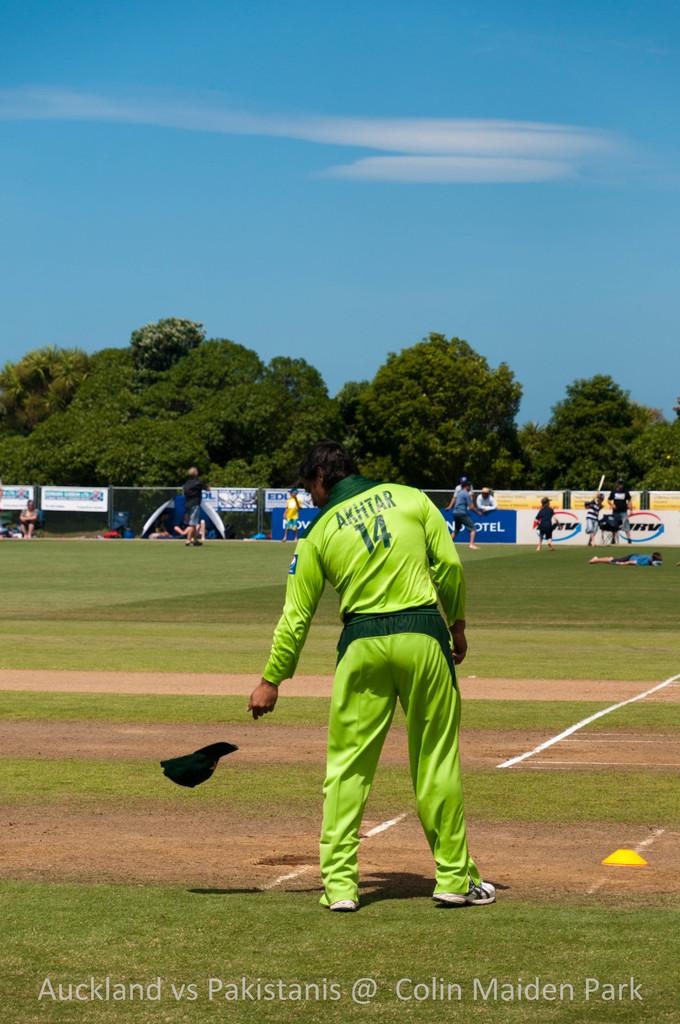What is the man in green's number?
Your response must be concise. 14. Is baseball popular outside of the us?
Your response must be concise. Unanswerable. 